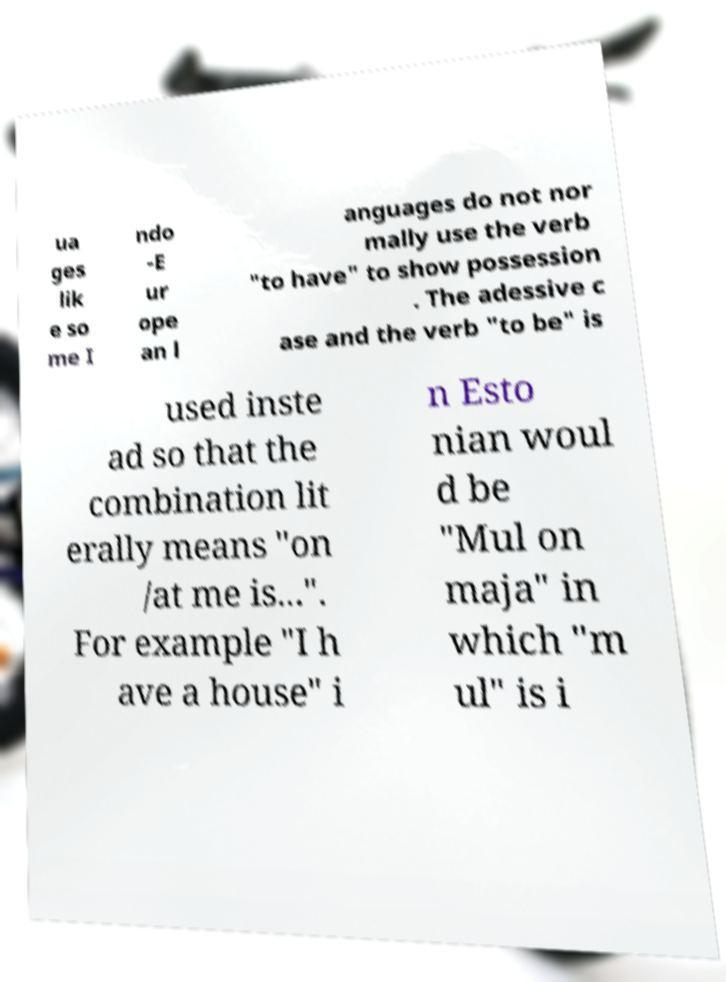Can you read and provide the text displayed in the image?This photo seems to have some interesting text. Can you extract and type it out for me? ua ges lik e so me I ndo -E ur ope an l anguages do not nor mally use the verb "to have" to show possession . The adessive c ase and the verb "to be" is used inste ad so that the combination lit erally means "on /at me is...". For example "I h ave a house" i n Esto nian woul d be "Mul on maja" in which "m ul" is i 